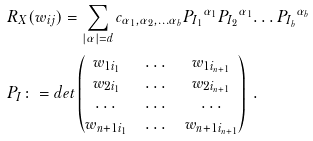<formula> <loc_0><loc_0><loc_500><loc_500>& R _ { X } ( w _ { i j } ) = \sum _ { | \alpha | = d } c _ { \alpha _ { 1 } , \alpha _ { 2 } , \dots \alpha _ { b } } { P _ { I _ { 1 } } } ^ { \alpha _ { 1 } } { P _ { I _ { 2 } } } ^ { \alpha _ { 1 } } { \dots P _ { I _ { b } } } ^ { \alpha _ { b } } \\ & P _ { I } \colon = d e t \begin{pmatrix} w _ { 1 i _ { 1 } } & \dots & w _ { 1 i _ { n + 1 } } \\ w _ { 2 i _ { 1 } } & \dots & w _ { 2 i _ { n + 1 } } \\ \dots & \dots & \dots \\ w _ { n + 1 i _ { 1 } } & \dots & w _ { n + 1 i _ { n + 1 } } \\ \end{pmatrix} \ .</formula> 